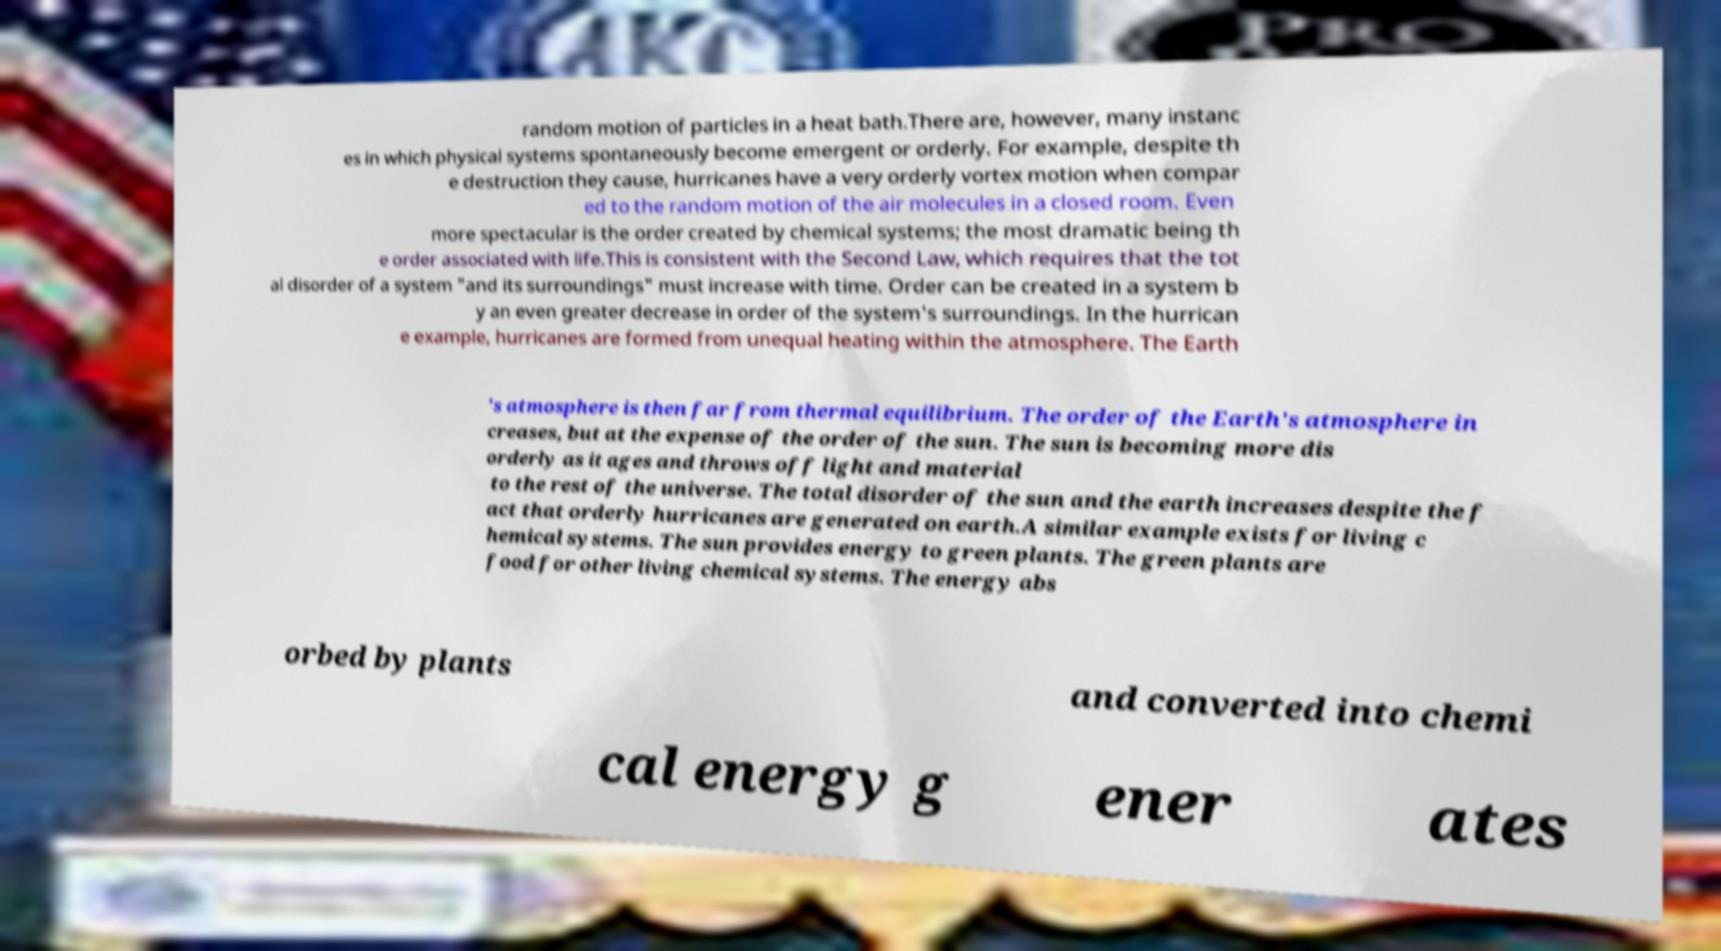There's text embedded in this image that I need extracted. Can you transcribe it verbatim? random motion of particles in a heat bath.There are, however, many instanc es in which physical systems spontaneously become emergent or orderly. For example, despite th e destruction they cause, hurricanes have a very orderly vortex motion when compar ed to the random motion of the air molecules in a closed room. Even more spectacular is the order created by chemical systems; the most dramatic being th e order associated with life.This is consistent with the Second Law, which requires that the tot al disorder of a system "and its surroundings" must increase with time. Order can be created in a system b y an even greater decrease in order of the system's surroundings. In the hurrican e example, hurricanes are formed from unequal heating within the atmosphere. The Earth 's atmosphere is then far from thermal equilibrium. The order of the Earth's atmosphere in creases, but at the expense of the order of the sun. The sun is becoming more dis orderly as it ages and throws off light and material to the rest of the universe. The total disorder of the sun and the earth increases despite the f act that orderly hurricanes are generated on earth.A similar example exists for living c hemical systems. The sun provides energy to green plants. The green plants are food for other living chemical systems. The energy abs orbed by plants and converted into chemi cal energy g ener ates 